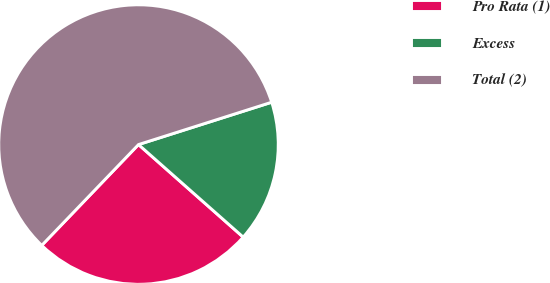Convert chart. <chart><loc_0><loc_0><loc_500><loc_500><pie_chart><fcel>Pro Rata (1)<fcel>Excess<fcel>Total (2)<nl><fcel>25.65%<fcel>16.42%<fcel>57.93%<nl></chart> 